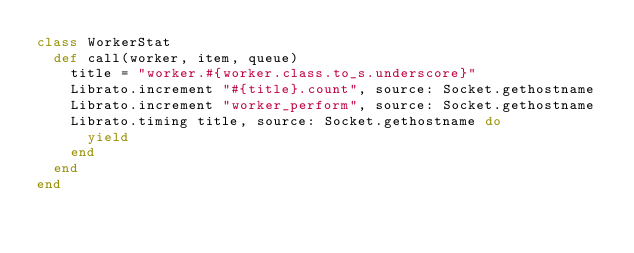Convert code to text. <code><loc_0><loc_0><loc_500><loc_500><_Ruby_>class WorkerStat
  def call(worker, item, queue)
    title = "worker.#{worker.class.to_s.underscore}"
    Librato.increment "#{title}.count", source: Socket.gethostname
    Librato.increment "worker_perform", source: Socket.gethostname
    Librato.timing title, source: Socket.gethostname do
      yield
    end
  end
end
</code> 